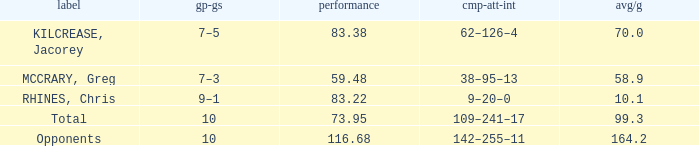Could you parse the entire table as a dict? {'header': ['label', 'gp-gs', 'performance', 'cmp-att-int', 'avg/g'], 'rows': [['KILCREASE, Jacorey', '7–5', '83.38', '62–126–4', '70.0'], ['MCCRARY, Greg', '7–3', '59.48', '38–95–13', '58.9'], ['RHINES, Chris', '9–1', '83.22', '9–20–0', '10.1'], ['Total', '10', '73.95', '109–241–17', '99.3'], ['Opponents', '10', '116.68', '142–255–11', '164.2']]} What is the lowest effic with a 58.9 avg/g? 59.48. 